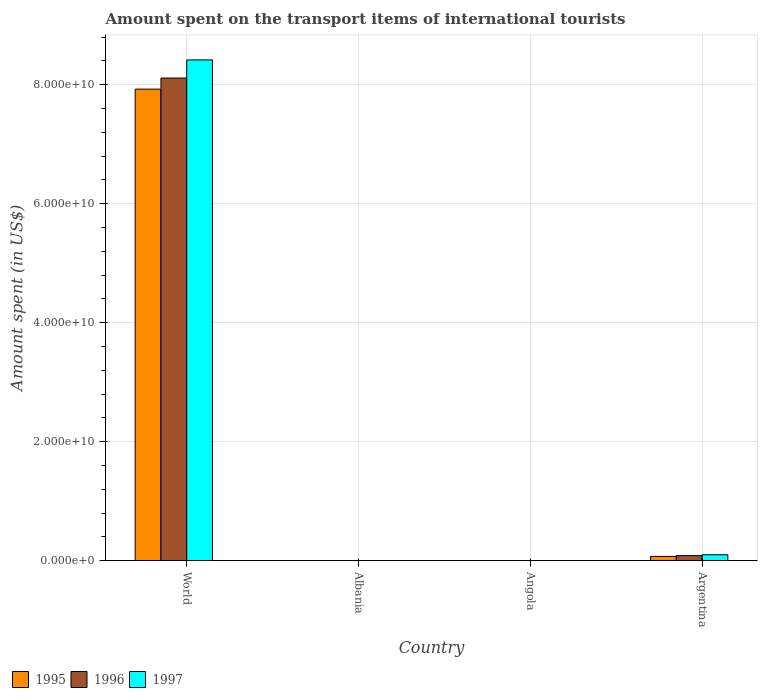How many groups of bars are there?
Give a very brief answer. 4. Are the number of bars per tick equal to the number of legend labels?
Your answer should be very brief. Yes. How many bars are there on the 3rd tick from the left?
Offer a terse response. 3. What is the label of the 3rd group of bars from the left?
Provide a short and direct response. Angola. In how many cases, is the number of bars for a given country not equal to the number of legend labels?
Your answer should be compact. 0. What is the amount spent on the transport items of international tourists in 1995 in Albania?
Provide a short and direct response. 1.20e+07. Across all countries, what is the maximum amount spent on the transport items of international tourists in 1997?
Your answer should be compact. 8.42e+1. Across all countries, what is the minimum amount spent on the transport items of international tourists in 1996?
Provide a short and direct response. 1.30e+07. In which country was the amount spent on the transport items of international tourists in 1996 maximum?
Provide a succinct answer. World. In which country was the amount spent on the transport items of international tourists in 1995 minimum?
Your answer should be very brief. Albania. What is the total amount spent on the transport items of international tourists in 1996 in the graph?
Ensure brevity in your answer.  8.20e+1. What is the difference between the amount spent on the transport items of international tourists in 1997 in Albania and that in Angola?
Your response must be concise. -1.92e+07. What is the difference between the amount spent on the transport items of international tourists in 1995 in Angola and the amount spent on the transport items of international tourists in 1996 in World?
Provide a short and direct response. -8.11e+1. What is the average amount spent on the transport items of international tourists in 1995 per country?
Provide a succinct answer. 2.00e+1. What is the difference between the amount spent on the transport items of international tourists of/in 1997 and amount spent on the transport items of international tourists of/in 1995 in Angola?
Make the answer very short. -1.06e+07. What is the ratio of the amount spent on the transport items of international tourists in 1995 in Angola to that in World?
Make the answer very short. 0. Is the amount spent on the transport items of international tourists in 1996 in Albania less than that in World?
Provide a succinct answer. Yes. Is the difference between the amount spent on the transport items of international tourists in 1997 in Albania and Angola greater than the difference between the amount spent on the transport items of international tourists in 1995 in Albania and Angola?
Offer a very short reply. Yes. What is the difference between the highest and the second highest amount spent on the transport items of international tourists in 1997?
Your answer should be very brief. -8.32e+1. What is the difference between the highest and the lowest amount spent on the transport items of international tourists in 1995?
Provide a short and direct response. 7.92e+1. Is the sum of the amount spent on the transport items of international tourists in 1997 in Albania and Angola greater than the maximum amount spent on the transport items of international tourists in 1995 across all countries?
Your response must be concise. No. What is the difference between two consecutive major ticks on the Y-axis?
Your answer should be very brief. 2.00e+1. Does the graph contain any zero values?
Make the answer very short. No. Does the graph contain grids?
Provide a short and direct response. Yes. Where does the legend appear in the graph?
Offer a very short reply. Bottom left. How many legend labels are there?
Your response must be concise. 3. What is the title of the graph?
Your response must be concise. Amount spent on the transport items of international tourists. What is the label or title of the X-axis?
Ensure brevity in your answer.  Country. What is the label or title of the Y-axis?
Provide a short and direct response. Amount spent (in US$). What is the Amount spent (in US$) in 1995 in World?
Your response must be concise. 7.93e+1. What is the Amount spent (in US$) in 1996 in World?
Keep it short and to the point. 8.11e+1. What is the Amount spent (in US$) in 1997 in World?
Your answer should be very brief. 8.42e+1. What is the Amount spent (in US$) in 1995 in Albania?
Your answer should be very brief. 1.20e+07. What is the Amount spent (in US$) in 1996 in Albania?
Keep it short and to the point. 1.30e+07. What is the Amount spent (in US$) in 1995 in Angola?
Keep it short and to the point. 3.78e+07. What is the Amount spent (in US$) in 1996 in Angola?
Your answer should be very brief. 3.74e+07. What is the Amount spent (in US$) of 1997 in Angola?
Ensure brevity in your answer.  2.72e+07. What is the Amount spent (in US$) of 1995 in Argentina?
Your answer should be compact. 7.35e+08. What is the Amount spent (in US$) of 1996 in Argentina?
Your answer should be very brief. 8.65e+08. What is the Amount spent (in US$) in 1997 in Argentina?
Offer a very short reply. 1.01e+09. Across all countries, what is the maximum Amount spent (in US$) of 1995?
Provide a short and direct response. 7.93e+1. Across all countries, what is the maximum Amount spent (in US$) of 1996?
Your response must be concise. 8.11e+1. Across all countries, what is the maximum Amount spent (in US$) of 1997?
Provide a succinct answer. 8.42e+1. Across all countries, what is the minimum Amount spent (in US$) of 1996?
Your answer should be very brief. 1.30e+07. What is the total Amount spent (in US$) in 1995 in the graph?
Your answer should be compact. 8.00e+1. What is the total Amount spent (in US$) of 1996 in the graph?
Provide a short and direct response. 8.20e+1. What is the total Amount spent (in US$) in 1997 in the graph?
Your answer should be compact. 8.52e+1. What is the difference between the Amount spent (in US$) of 1995 in World and that in Albania?
Give a very brief answer. 7.92e+1. What is the difference between the Amount spent (in US$) in 1996 in World and that in Albania?
Make the answer very short. 8.11e+1. What is the difference between the Amount spent (in US$) of 1997 in World and that in Albania?
Offer a terse response. 8.42e+1. What is the difference between the Amount spent (in US$) of 1995 in World and that in Angola?
Provide a succinct answer. 7.92e+1. What is the difference between the Amount spent (in US$) in 1996 in World and that in Angola?
Keep it short and to the point. 8.11e+1. What is the difference between the Amount spent (in US$) in 1997 in World and that in Angola?
Give a very brief answer. 8.41e+1. What is the difference between the Amount spent (in US$) in 1995 in World and that in Argentina?
Provide a succinct answer. 7.85e+1. What is the difference between the Amount spent (in US$) in 1996 in World and that in Argentina?
Ensure brevity in your answer.  8.03e+1. What is the difference between the Amount spent (in US$) of 1997 in World and that in Argentina?
Give a very brief answer. 8.32e+1. What is the difference between the Amount spent (in US$) of 1995 in Albania and that in Angola?
Provide a succinct answer. -2.58e+07. What is the difference between the Amount spent (in US$) of 1996 in Albania and that in Angola?
Provide a succinct answer. -2.44e+07. What is the difference between the Amount spent (in US$) of 1997 in Albania and that in Angola?
Provide a short and direct response. -1.92e+07. What is the difference between the Amount spent (in US$) of 1995 in Albania and that in Argentina?
Your answer should be very brief. -7.23e+08. What is the difference between the Amount spent (in US$) of 1996 in Albania and that in Argentina?
Offer a terse response. -8.52e+08. What is the difference between the Amount spent (in US$) of 1997 in Albania and that in Argentina?
Offer a very short reply. -1.00e+09. What is the difference between the Amount spent (in US$) of 1995 in Angola and that in Argentina?
Your response must be concise. -6.97e+08. What is the difference between the Amount spent (in US$) of 1996 in Angola and that in Argentina?
Provide a succinct answer. -8.28e+08. What is the difference between the Amount spent (in US$) in 1997 in Angola and that in Argentina?
Give a very brief answer. -9.84e+08. What is the difference between the Amount spent (in US$) of 1995 in World and the Amount spent (in US$) of 1996 in Albania?
Your answer should be very brief. 7.92e+1. What is the difference between the Amount spent (in US$) in 1995 in World and the Amount spent (in US$) in 1997 in Albania?
Your answer should be compact. 7.92e+1. What is the difference between the Amount spent (in US$) of 1996 in World and the Amount spent (in US$) of 1997 in Albania?
Your answer should be compact. 8.11e+1. What is the difference between the Amount spent (in US$) of 1995 in World and the Amount spent (in US$) of 1996 in Angola?
Offer a very short reply. 7.92e+1. What is the difference between the Amount spent (in US$) of 1995 in World and the Amount spent (in US$) of 1997 in Angola?
Your answer should be very brief. 7.92e+1. What is the difference between the Amount spent (in US$) of 1996 in World and the Amount spent (in US$) of 1997 in Angola?
Give a very brief answer. 8.11e+1. What is the difference between the Amount spent (in US$) in 1995 in World and the Amount spent (in US$) in 1996 in Argentina?
Offer a very short reply. 7.84e+1. What is the difference between the Amount spent (in US$) of 1995 in World and the Amount spent (in US$) of 1997 in Argentina?
Provide a succinct answer. 7.82e+1. What is the difference between the Amount spent (in US$) in 1996 in World and the Amount spent (in US$) in 1997 in Argentina?
Your answer should be compact. 8.01e+1. What is the difference between the Amount spent (in US$) in 1995 in Albania and the Amount spent (in US$) in 1996 in Angola?
Your response must be concise. -2.54e+07. What is the difference between the Amount spent (in US$) of 1995 in Albania and the Amount spent (in US$) of 1997 in Angola?
Offer a terse response. -1.52e+07. What is the difference between the Amount spent (in US$) of 1996 in Albania and the Amount spent (in US$) of 1997 in Angola?
Your answer should be compact. -1.42e+07. What is the difference between the Amount spent (in US$) of 1995 in Albania and the Amount spent (in US$) of 1996 in Argentina?
Your response must be concise. -8.53e+08. What is the difference between the Amount spent (in US$) in 1995 in Albania and the Amount spent (in US$) in 1997 in Argentina?
Offer a terse response. -9.99e+08. What is the difference between the Amount spent (in US$) in 1996 in Albania and the Amount spent (in US$) in 1997 in Argentina?
Keep it short and to the point. -9.98e+08. What is the difference between the Amount spent (in US$) of 1995 in Angola and the Amount spent (in US$) of 1996 in Argentina?
Offer a terse response. -8.27e+08. What is the difference between the Amount spent (in US$) in 1995 in Angola and the Amount spent (in US$) in 1997 in Argentina?
Give a very brief answer. -9.73e+08. What is the difference between the Amount spent (in US$) in 1996 in Angola and the Amount spent (in US$) in 1997 in Argentina?
Your response must be concise. -9.74e+08. What is the average Amount spent (in US$) of 1995 per country?
Offer a terse response. 2.00e+1. What is the average Amount spent (in US$) in 1996 per country?
Keep it short and to the point. 2.05e+1. What is the average Amount spent (in US$) of 1997 per country?
Make the answer very short. 2.13e+1. What is the difference between the Amount spent (in US$) of 1995 and Amount spent (in US$) of 1996 in World?
Give a very brief answer. -1.87e+09. What is the difference between the Amount spent (in US$) in 1995 and Amount spent (in US$) in 1997 in World?
Offer a very short reply. -4.91e+09. What is the difference between the Amount spent (in US$) in 1996 and Amount spent (in US$) in 1997 in World?
Your answer should be compact. -3.04e+09. What is the difference between the Amount spent (in US$) of 1995 and Amount spent (in US$) of 1996 in Albania?
Give a very brief answer. -1.00e+06. What is the difference between the Amount spent (in US$) in 1995 and Amount spent (in US$) in 1997 in Albania?
Provide a short and direct response. 4.00e+06. What is the difference between the Amount spent (in US$) in 1995 and Amount spent (in US$) in 1996 in Angola?
Offer a terse response. 4.50e+05. What is the difference between the Amount spent (in US$) of 1995 and Amount spent (in US$) of 1997 in Angola?
Ensure brevity in your answer.  1.06e+07. What is the difference between the Amount spent (in US$) in 1996 and Amount spent (in US$) in 1997 in Angola?
Provide a succinct answer. 1.02e+07. What is the difference between the Amount spent (in US$) in 1995 and Amount spent (in US$) in 1996 in Argentina?
Your response must be concise. -1.30e+08. What is the difference between the Amount spent (in US$) in 1995 and Amount spent (in US$) in 1997 in Argentina?
Offer a very short reply. -2.76e+08. What is the difference between the Amount spent (in US$) of 1996 and Amount spent (in US$) of 1997 in Argentina?
Give a very brief answer. -1.46e+08. What is the ratio of the Amount spent (in US$) in 1995 in World to that in Albania?
Provide a short and direct response. 6604.42. What is the ratio of the Amount spent (in US$) of 1996 in World to that in Albania?
Give a very brief answer. 6239.88. What is the ratio of the Amount spent (in US$) of 1997 in World to that in Albania?
Provide a short and direct response. 1.05e+04. What is the ratio of the Amount spent (in US$) of 1995 in World to that in Angola?
Provide a short and direct response. 2095.59. What is the ratio of the Amount spent (in US$) of 1996 in World to that in Angola?
Give a very brief answer. 2170.74. What is the ratio of the Amount spent (in US$) in 1997 in World to that in Angola?
Your answer should be very brief. 3094.22. What is the ratio of the Amount spent (in US$) in 1995 in World to that in Argentina?
Give a very brief answer. 107.83. What is the ratio of the Amount spent (in US$) in 1996 in World to that in Argentina?
Your response must be concise. 93.78. What is the ratio of the Amount spent (in US$) of 1997 in World to that in Argentina?
Offer a very short reply. 83.25. What is the ratio of the Amount spent (in US$) of 1995 in Albania to that in Angola?
Make the answer very short. 0.32. What is the ratio of the Amount spent (in US$) in 1996 in Albania to that in Angola?
Ensure brevity in your answer.  0.35. What is the ratio of the Amount spent (in US$) in 1997 in Albania to that in Angola?
Give a very brief answer. 0.29. What is the ratio of the Amount spent (in US$) of 1995 in Albania to that in Argentina?
Give a very brief answer. 0.02. What is the ratio of the Amount spent (in US$) in 1996 in Albania to that in Argentina?
Your response must be concise. 0.01. What is the ratio of the Amount spent (in US$) of 1997 in Albania to that in Argentina?
Ensure brevity in your answer.  0.01. What is the ratio of the Amount spent (in US$) in 1995 in Angola to that in Argentina?
Provide a short and direct response. 0.05. What is the ratio of the Amount spent (in US$) of 1996 in Angola to that in Argentina?
Your answer should be compact. 0.04. What is the ratio of the Amount spent (in US$) of 1997 in Angola to that in Argentina?
Offer a terse response. 0.03. What is the difference between the highest and the second highest Amount spent (in US$) in 1995?
Provide a succinct answer. 7.85e+1. What is the difference between the highest and the second highest Amount spent (in US$) of 1996?
Offer a terse response. 8.03e+1. What is the difference between the highest and the second highest Amount spent (in US$) of 1997?
Your response must be concise. 8.32e+1. What is the difference between the highest and the lowest Amount spent (in US$) in 1995?
Ensure brevity in your answer.  7.92e+1. What is the difference between the highest and the lowest Amount spent (in US$) of 1996?
Provide a short and direct response. 8.11e+1. What is the difference between the highest and the lowest Amount spent (in US$) of 1997?
Your answer should be very brief. 8.42e+1. 